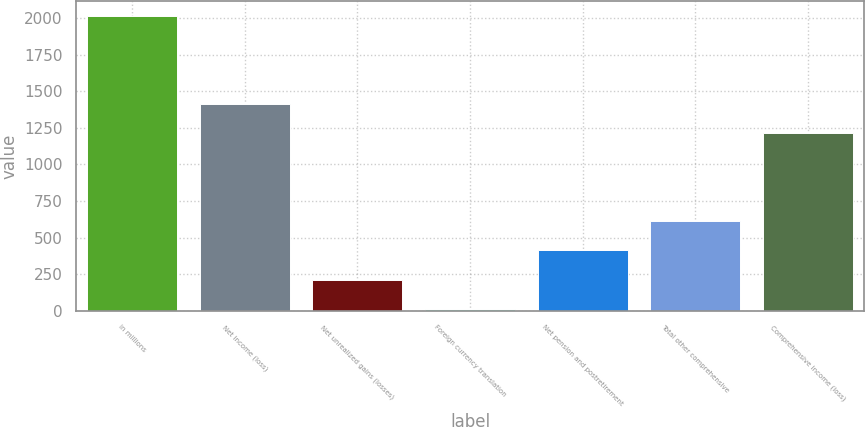Convert chart. <chart><loc_0><loc_0><loc_500><loc_500><bar_chart><fcel>in millions<fcel>Net income (loss)<fcel>Net unrealized gains (losses)<fcel>Foreign currency translation<fcel>Net pension and postretirement<fcel>Total other comprehensive<fcel>Comprehensive income (loss)<nl><fcel>2013<fcel>1413<fcel>213<fcel>13<fcel>413<fcel>613<fcel>1213<nl></chart> 